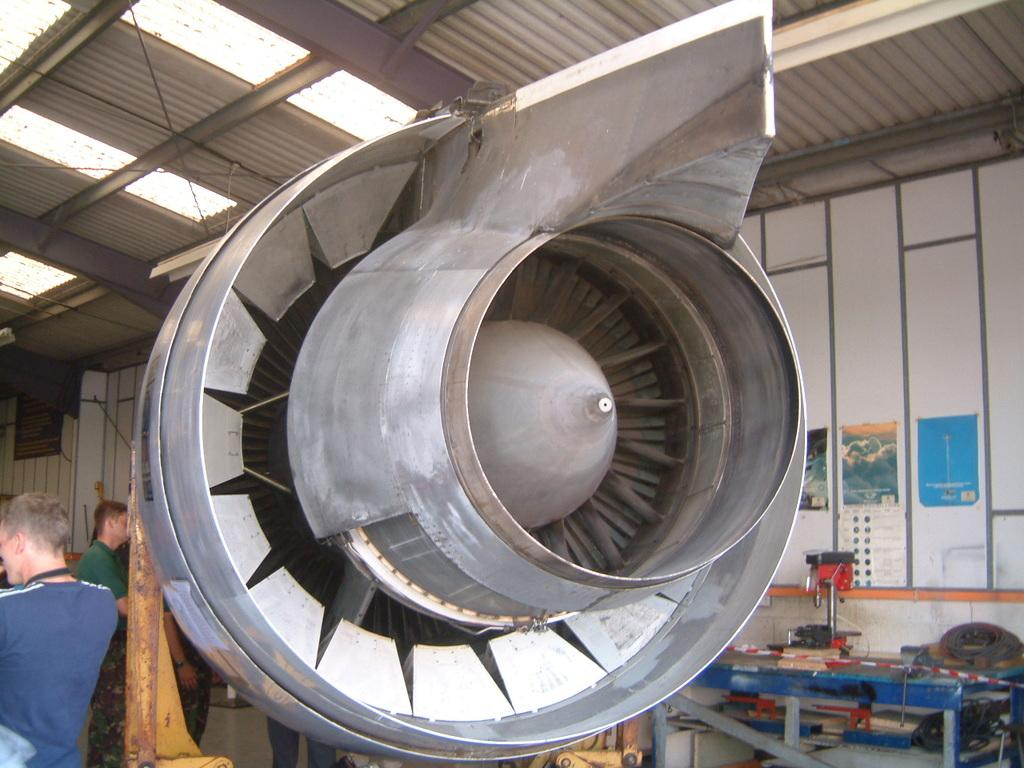What can be seen in the image involving people? There are people standing in the image. What type of equipment is present in the image? There is a machine in the image. What piece of furniture is visible in the image? There is a table in the image. What are some of the items or objects in the image? There are objects in the image. What safety measure is taken in the image? Caution tape is present in the image. What is on the wall in the image? There are posters on the wall in the image. What can be seen at the top of the image? Lights are visible at the top of the image. What songs are being sung by the frogs in the image? There are no frogs present in the image, and therefore no songs can be heard. What type of substance is being processed by the machine in the image? The image does not provide information about the substance being processed by the machine. 